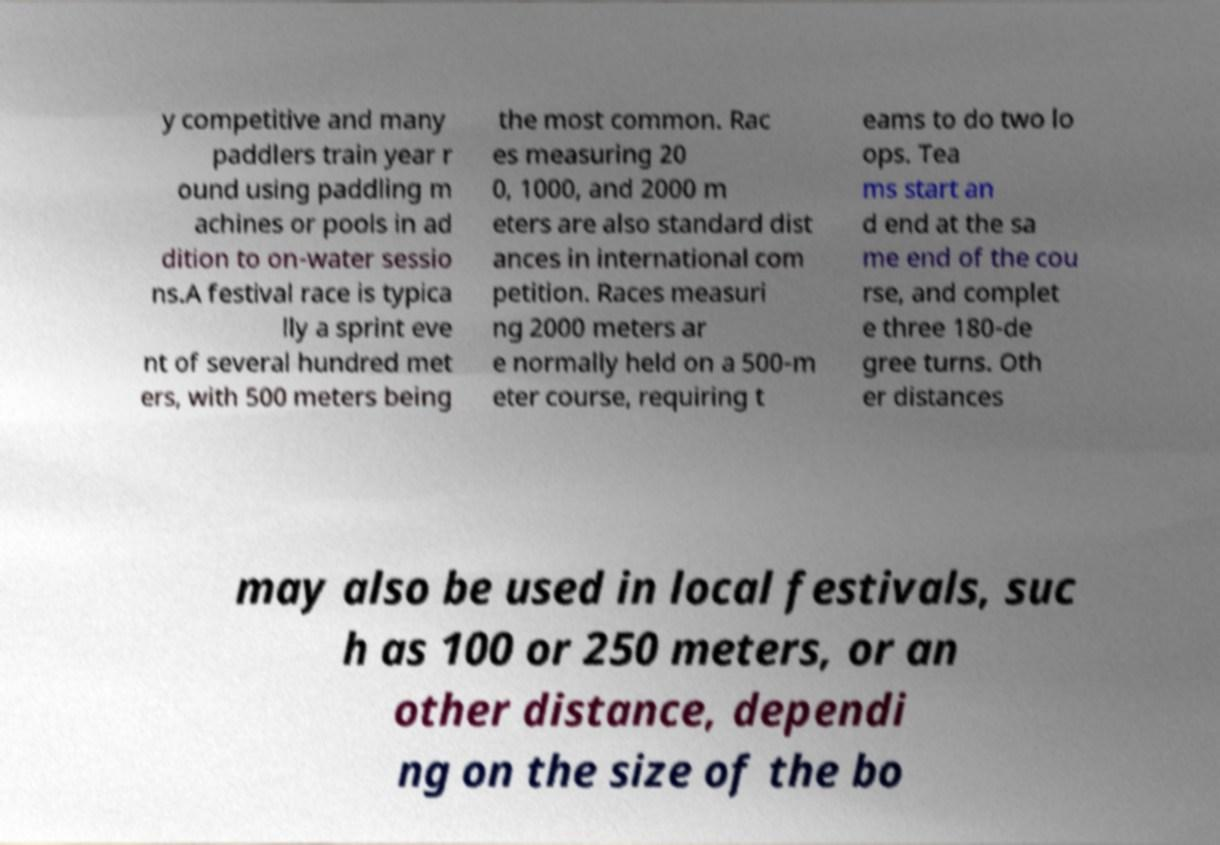For documentation purposes, I need the text within this image transcribed. Could you provide that? y competitive and many paddlers train year r ound using paddling m achines or pools in ad dition to on-water sessio ns.A festival race is typica lly a sprint eve nt of several hundred met ers, with 500 meters being the most common. Rac es measuring 20 0, 1000, and 2000 m eters are also standard dist ances in international com petition. Races measuri ng 2000 meters ar e normally held on a 500-m eter course, requiring t eams to do two lo ops. Tea ms start an d end at the sa me end of the cou rse, and complet e three 180-de gree turns. Oth er distances may also be used in local festivals, suc h as 100 or 250 meters, or an other distance, dependi ng on the size of the bo 